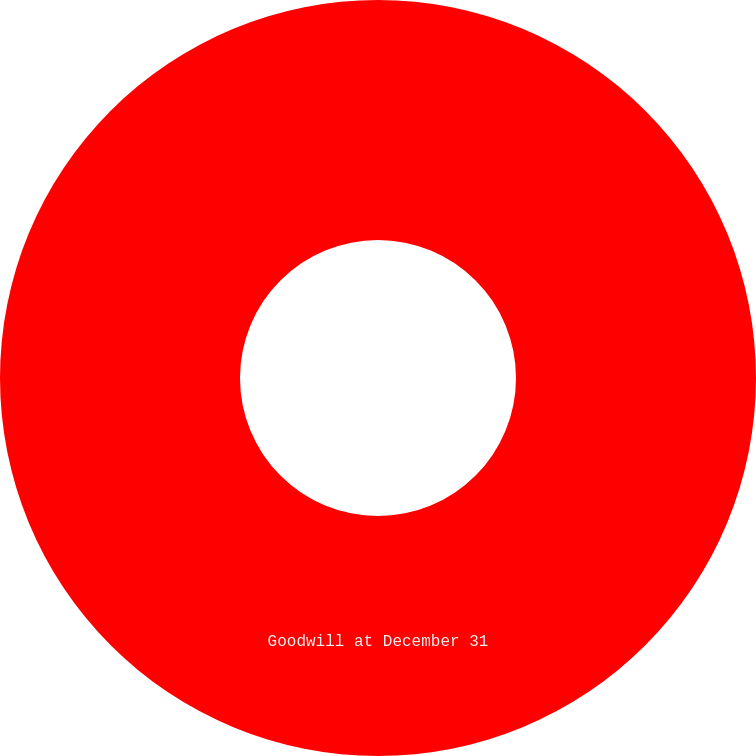Convert chart. <chart><loc_0><loc_0><loc_500><loc_500><pie_chart><fcel>Goodwill at December 31<nl><fcel>100.0%<nl></chart> 